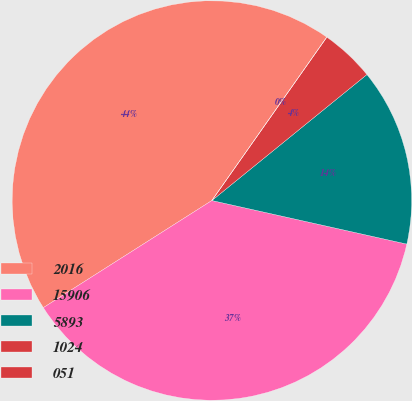Convert chart to OTSL. <chart><loc_0><loc_0><loc_500><loc_500><pie_chart><fcel>2016<fcel>15906<fcel>5893<fcel>1024<fcel>051<nl><fcel>43.76%<fcel>37.49%<fcel>14.36%<fcel>4.38%<fcel>0.01%<nl></chart> 